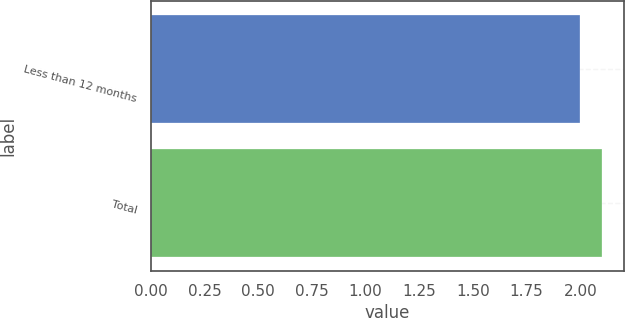Convert chart. <chart><loc_0><loc_0><loc_500><loc_500><bar_chart><fcel>Less than 12 months<fcel>Total<nl><fcel>2<fcel>2.1<nl></chart> 